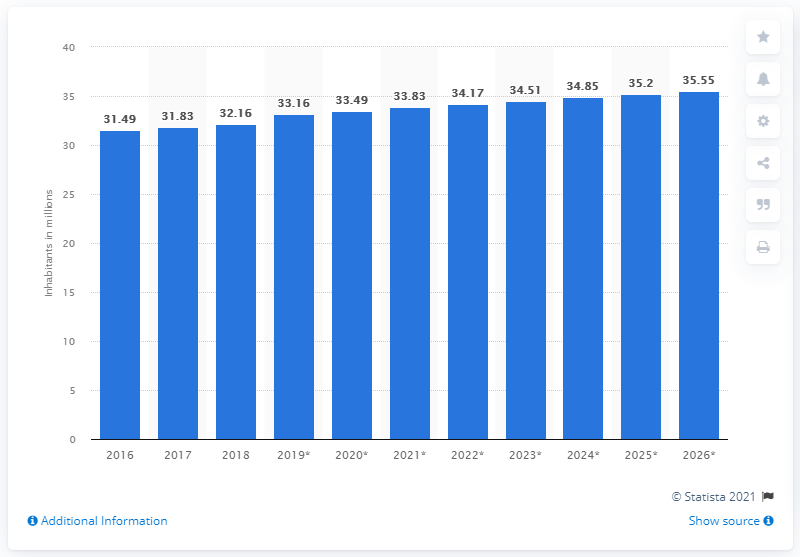Specify some key components in this picture. In 2018, the population of Peru was 32.16 million. 